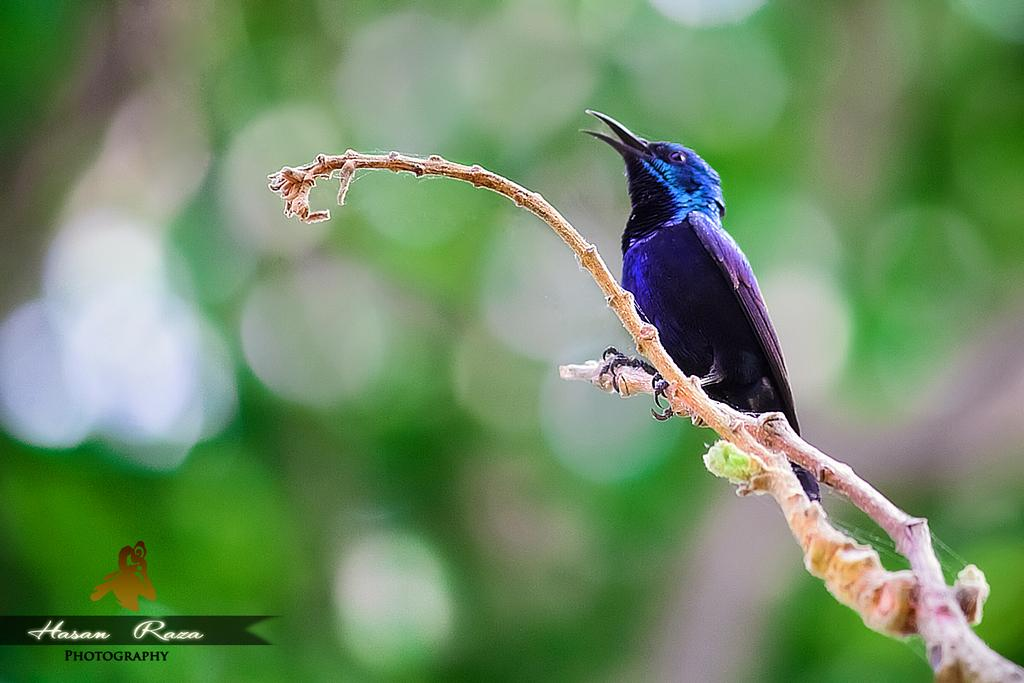What type of animal can be seen in the image? There is a bird in the image. Where is the bird located in the image? The bird is sitting on a branch of a plant. What type of yam can be seen growing on the branch next to the bird in the image? There is no yam present in the image; it features a bird sitting on a branch of a plant. 